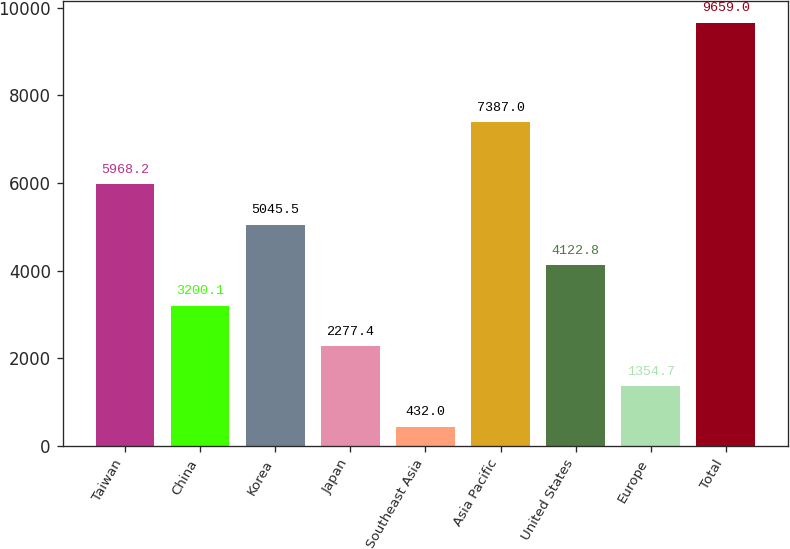<chart> <loc_0><loc_0><loc_500><loc_500><bar_chart><fcel>Taiwan<fcel>China<fcel>Korea<fcel>Japan<fcel>Southeast Asia<fcel>Asia Pacific<fcel>United States<fcel>Europe<fcel>Total<nl><fcel>5968.2<fcel>3200.1<fcel>5045.5<fcel>2277.4<fcel>432<fcel>7387<fcel>4122.8<fcel>1354.7<fcel>9659<nl></chart> 